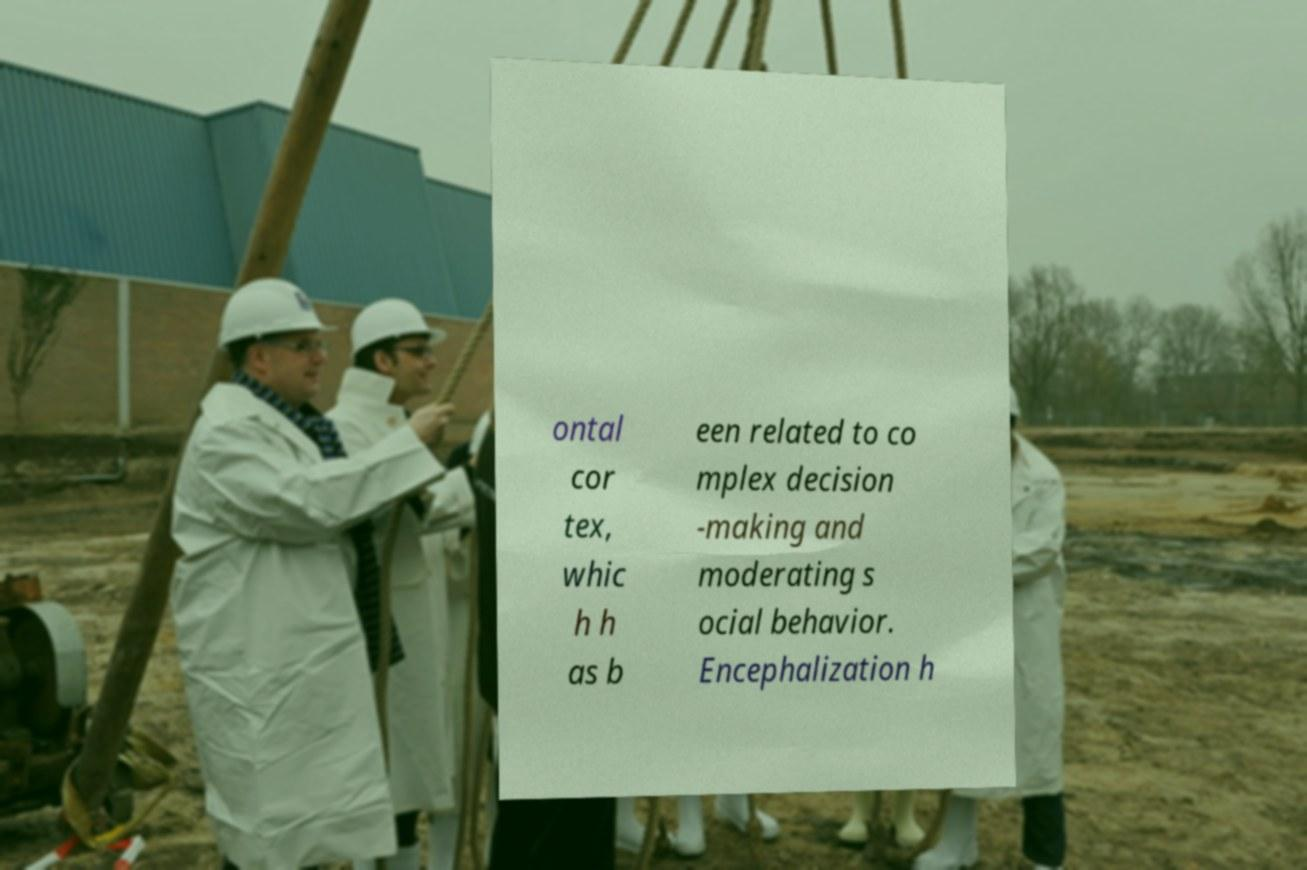There's text embedded in this image that I need extracted. Can you transcribe it verbatim? ontal cor tex, whic h h as b een related to co mplex decision -making and moderating s ocial behavior. Encephalization h 